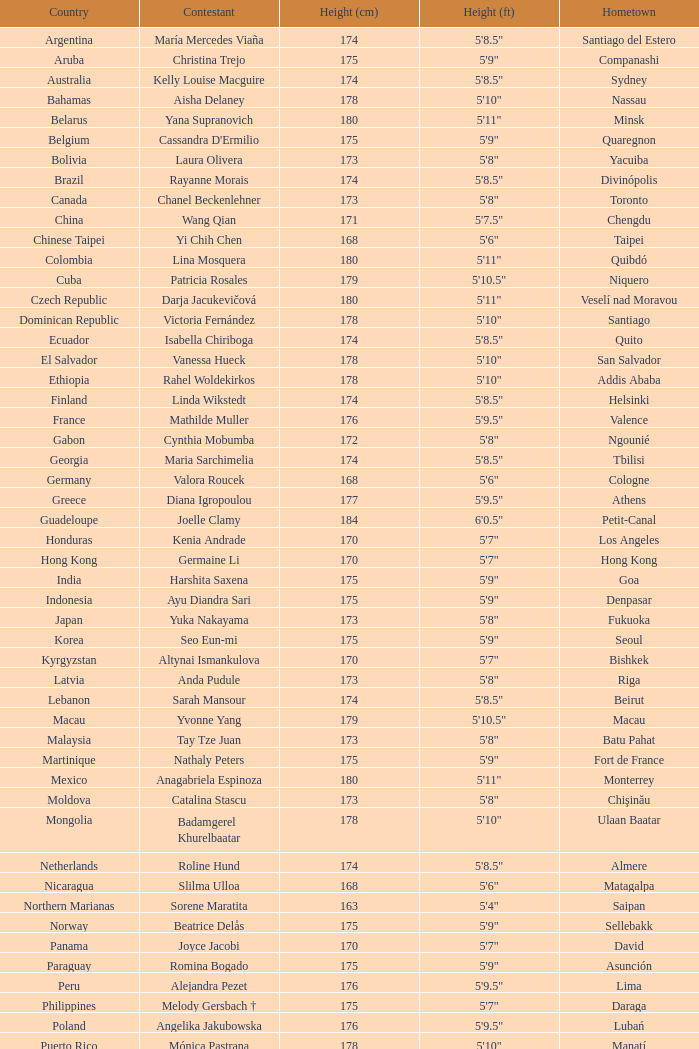What is the hometown of the player from Indonesia? Denpasar. Give me the full table as a dictionary. {'header': ['Country', 'Contestant', 'Height (cm)', 'Height (ft)', 'Hometown'], 'rows': [['Argentina', 'María Mercedes Viaña', '174', '5\'8.5"', 'Santiago del Estero'], ['Aruba', 'Christina Trejo', '175', '5\'9"', 'Companashi'], ['Australia', 'Kelly Louise Macguire', '174', '5\'8.5"', 'Sydney'], ['Bahamas', 'Aisha Delaney', '178', '5\'10"', 'Nassau'], ['Belarus', 'Yana Supranovich', '180', '5\'11"', 'Minsk'], ['Belgium', "Cassandra D'Ermilio", '175', '5\'9"', 'Quaregnon'], ['Bolivia', 'Laura Olivera', '173', '5\'8"', 'Yacuiba'], ['Brazil', 'Rayanne Morais', '174', '5\'8.5"', 'Divinópolis'], ['Canada', 'Chanel Beckenlehner', '173', '5\'8"', 'Toronto'], ['China', 'Wang Qian', '171', '5\'7.5"', 'Chengdu'], ['Chinese Taipei', 'Yi Chih Chen', '168', '5\'6"', 'Taipei'], ['Colombia', 'Lina Mosquera', '180', '5\'11"', 'Quibdó'], ['Cuba', 'Patricia Rosales', '179', '5\'10.5"', 'Niquero'], ['Czech Republic', 'Darja Jacukevičová', '180', '5\'11"', 'Veselí nad Moravou'], ['Dominican Republic', 'Victoria Fernández', '178', '5\'10"', 'Santiago'], ['Ecuador', 'Isabella Chiriboga', '174', '5\'8.5"', 'Quito'], ['El Salvador', 'Vanessa Hueck', '178', '5\'10"', 'San Salvador'], ['Ethiopia', 'Rahel Woldekirkos', '178', '5\'10"', 'Addis Ababa'], ['Finland', 'Linda Wikstedt', '174', '5\'8.5"', 'Helsinki'], ['France', 'Mathilde Muller', '176', '5\'9.5"', 'Valence'], ['Gabon', 'Cynthia Mobumba', '172', '5\'8"', 'Ngounié'], ['Georgia', 'Maria Sarchimelia', '174', '5\'8.5"', 'Tbilisi'], ['Germany', 'Valora Roucek', '168', '5\'6"', 'Cologne'], ['Greece', 'Diana Igropoulou', '177', '5\'9.5"', 'Athens'], ['Guadeloupe', 'Joelle Clamy', '184', '6\'0.5"', 'Petit-Canal'], ['Honduras', 'Kenia Andrade', '170', '5\'7"', 'Los Angeles'], ['Hong Kong', 'Germaine Li', '170', '5\'7"', 'Hong Kong'], ['India', 'Harshita Saxena', '175', '5\'9"', 'Goa'], ['Indonesia', 'Ayu Diandra Sari', '175', '5\'9"', 'Denpasar'], ['Japan', 'Yuka Nakayama', '173', '5\'8"', 'Fukuoka'], ['Korea', 'Seo Eun-mi', '175', '5\'9"', 'Seoul'], ['Kyrgyzstan', 'Altynai Ismankulova', '170', '5\'7"', 'Bishkek'], ['Latvia', 'Anda Pudule', '173', '5\'8"', 'Riga'], ['Lebanon', 'Sarah Mansour', '174', '5\'8.5"', 'Beirut'], ['Macau', 'Yvonne Yang', '179', '5\'10.5"', 'Macau'], ['Malaysia', 'Tay Tze Juan', '173', '5\'8"', 'Batu Pahat'], ['Martinique', 'Nathaly Peters', '175', '5\'9"', 'Fort de France'], ['Mexico', 'Anagabriela Espinoza', '180', '5\'11"', 'Monterrey'], ['Moldova', 'Catalina Stascu', '173', '5\'8"', 'Chişinău'], ['Mongolia', 'Badamgerel Khurelbaatar', '178', '5\'10"', 'Ulaan Baatar'], ['Netherlands', 'Roline Hund', '174', '5\'8.5"', 'Almere'], ['Nicaragua', 'Slilma Ulloa', '168', '5\'6"', 'Matagalpa'], ['Northern Marianas', 'Sorene Maratita', '163', '5\'4"', 'Saipan'], ['Norway', 'Beatrice Delås', '175', '5\'9"', 'Sellebakk'], ['Panama', 'Joyce Jacobi', '170', '5\'7"', 'David'], ['Paraguay', 'Romina Bogado', '175', '5\'9"', 'Asunción'], ['Peru', 'Alejandra Pezet', '176', '5\'9.5"', 'Lima'], ['Philippines', 'Melody Gersbach †', '175', '5\'7"', 'Daraga'], ['Poland', 'Angelika Jakubowska', '176', '5\'9.5"', 'Lubań'], ['Puerto Rico', 'Mónica Pastrana', '178', '5\'10"', 'Manatí'], ['Romania', 'Iuliana Capsuc', '174', '5\'8.5"', 'Bucharest'], ['Russia', 'Ksenia Hrabovskaya', '176', '5\'9.5"', 'Khabarovsk'], ['Singapore', 'Annabelle Liang', '169', '5\'6.5"', 'Singapore'], ['Slovakia', 'Soňa Skoncová', '174', '5\'8.5"', 'Prievidza'], ['South Africa', 'Bokang Montjane', '174', '5\'8.5"', 'Johannesburg'], ['Spain', 'Melania Santiago', '174', '5\'8.5"', 'Málaga'], ['Sudan', 'Suna William', '168', '5\'6"', 'Darfur'], ['Tanzania', 'Illuminata James', '176', '5\'9.5"', 'Mwanza'], ['Thailand', 'Picha Nampradit', '178', '5\'10"', 'Kanchanaburi'], ['Turkey', 'Begüm Yılmaz', '180', '5\'11"', 'Izmir'], ['Uganda', 'Pierra Akwero', '177', '5\'9.5"', 'Entebbe'], ['United Kingdom', 'Chloe-Beth Morgan', '171', '5\'7.5"', 'Cwmbran'], ['USA', 'Aileen Jan Yap', '170', '5\'6"', 'Houston'], ['Venezuela', 'Laksmi Rodríguez', '178', '5\'10"', 'Caracas'], ['Vietnam', 'Trần Thị Quỳnh', '175', '5\'9"', 'Hai Phong']]} 